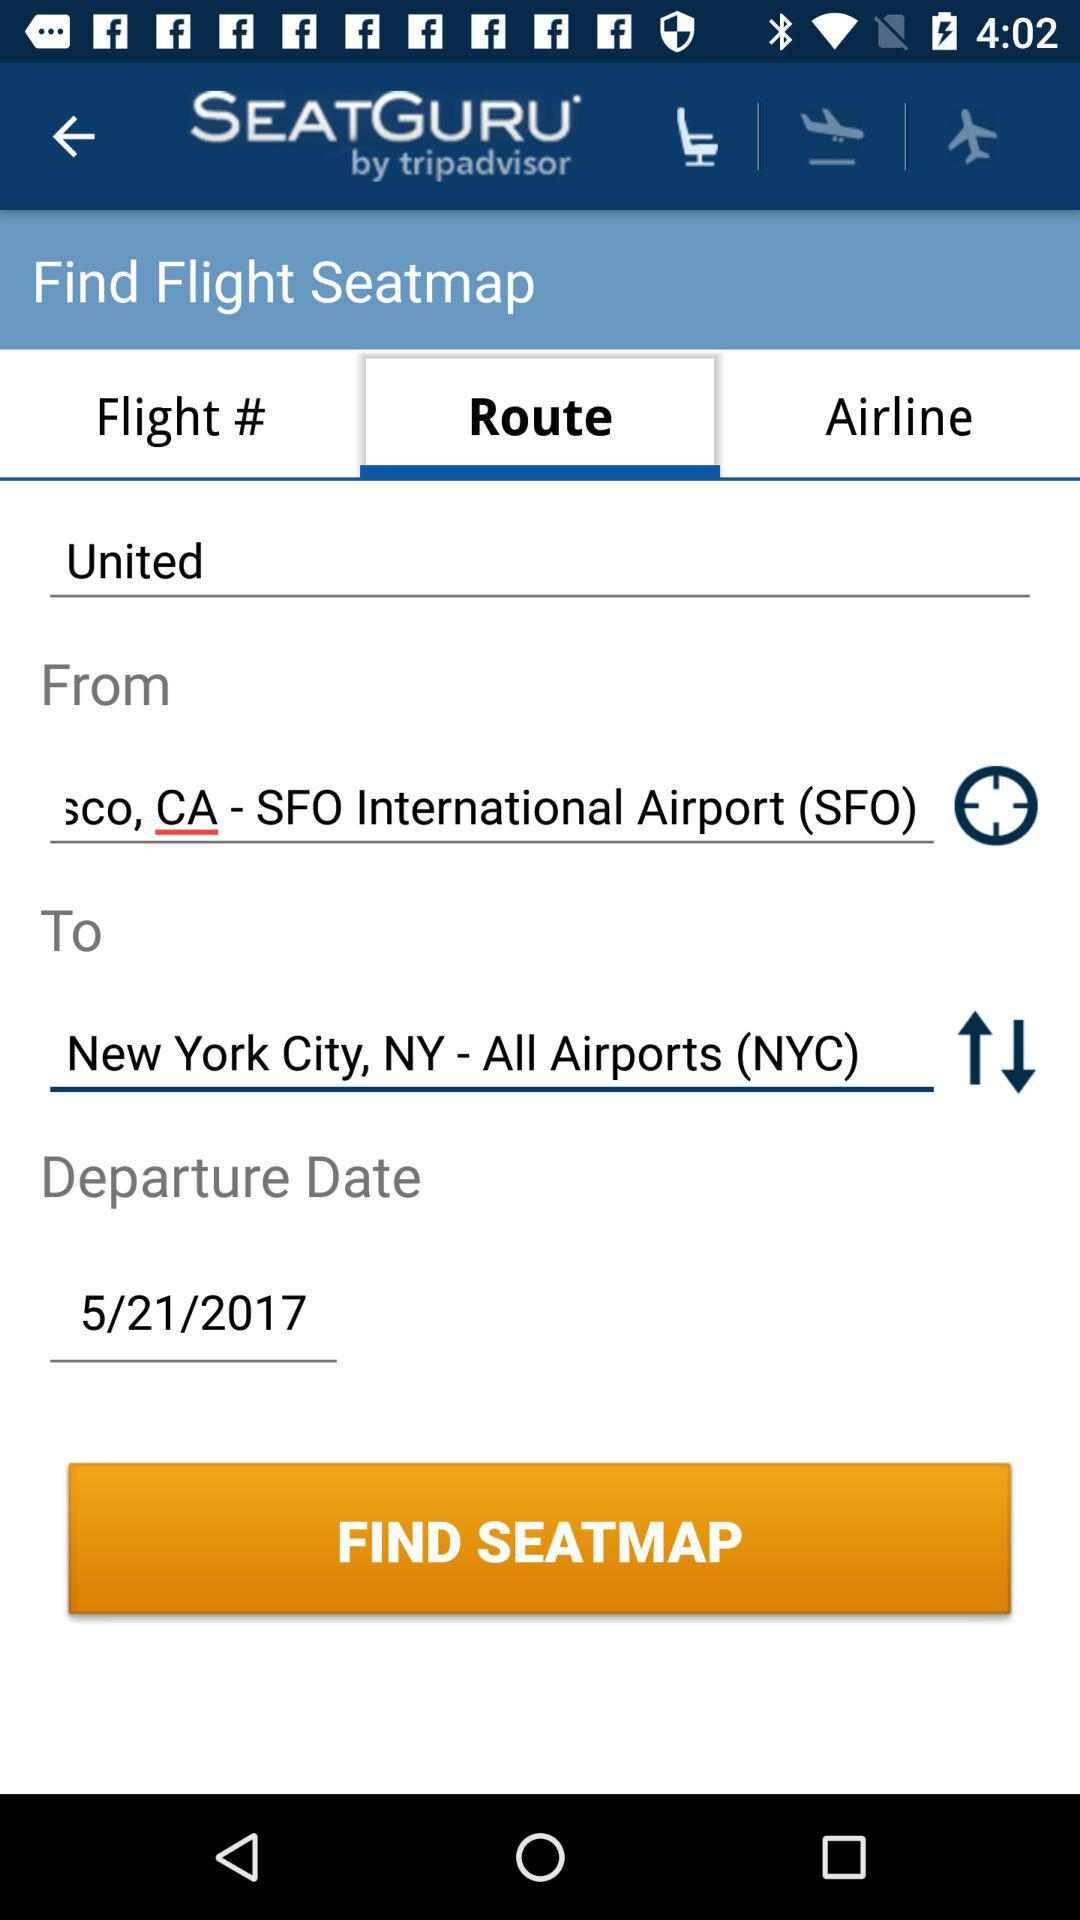Which tab is currently selected? The currently selected tab is "Route". 